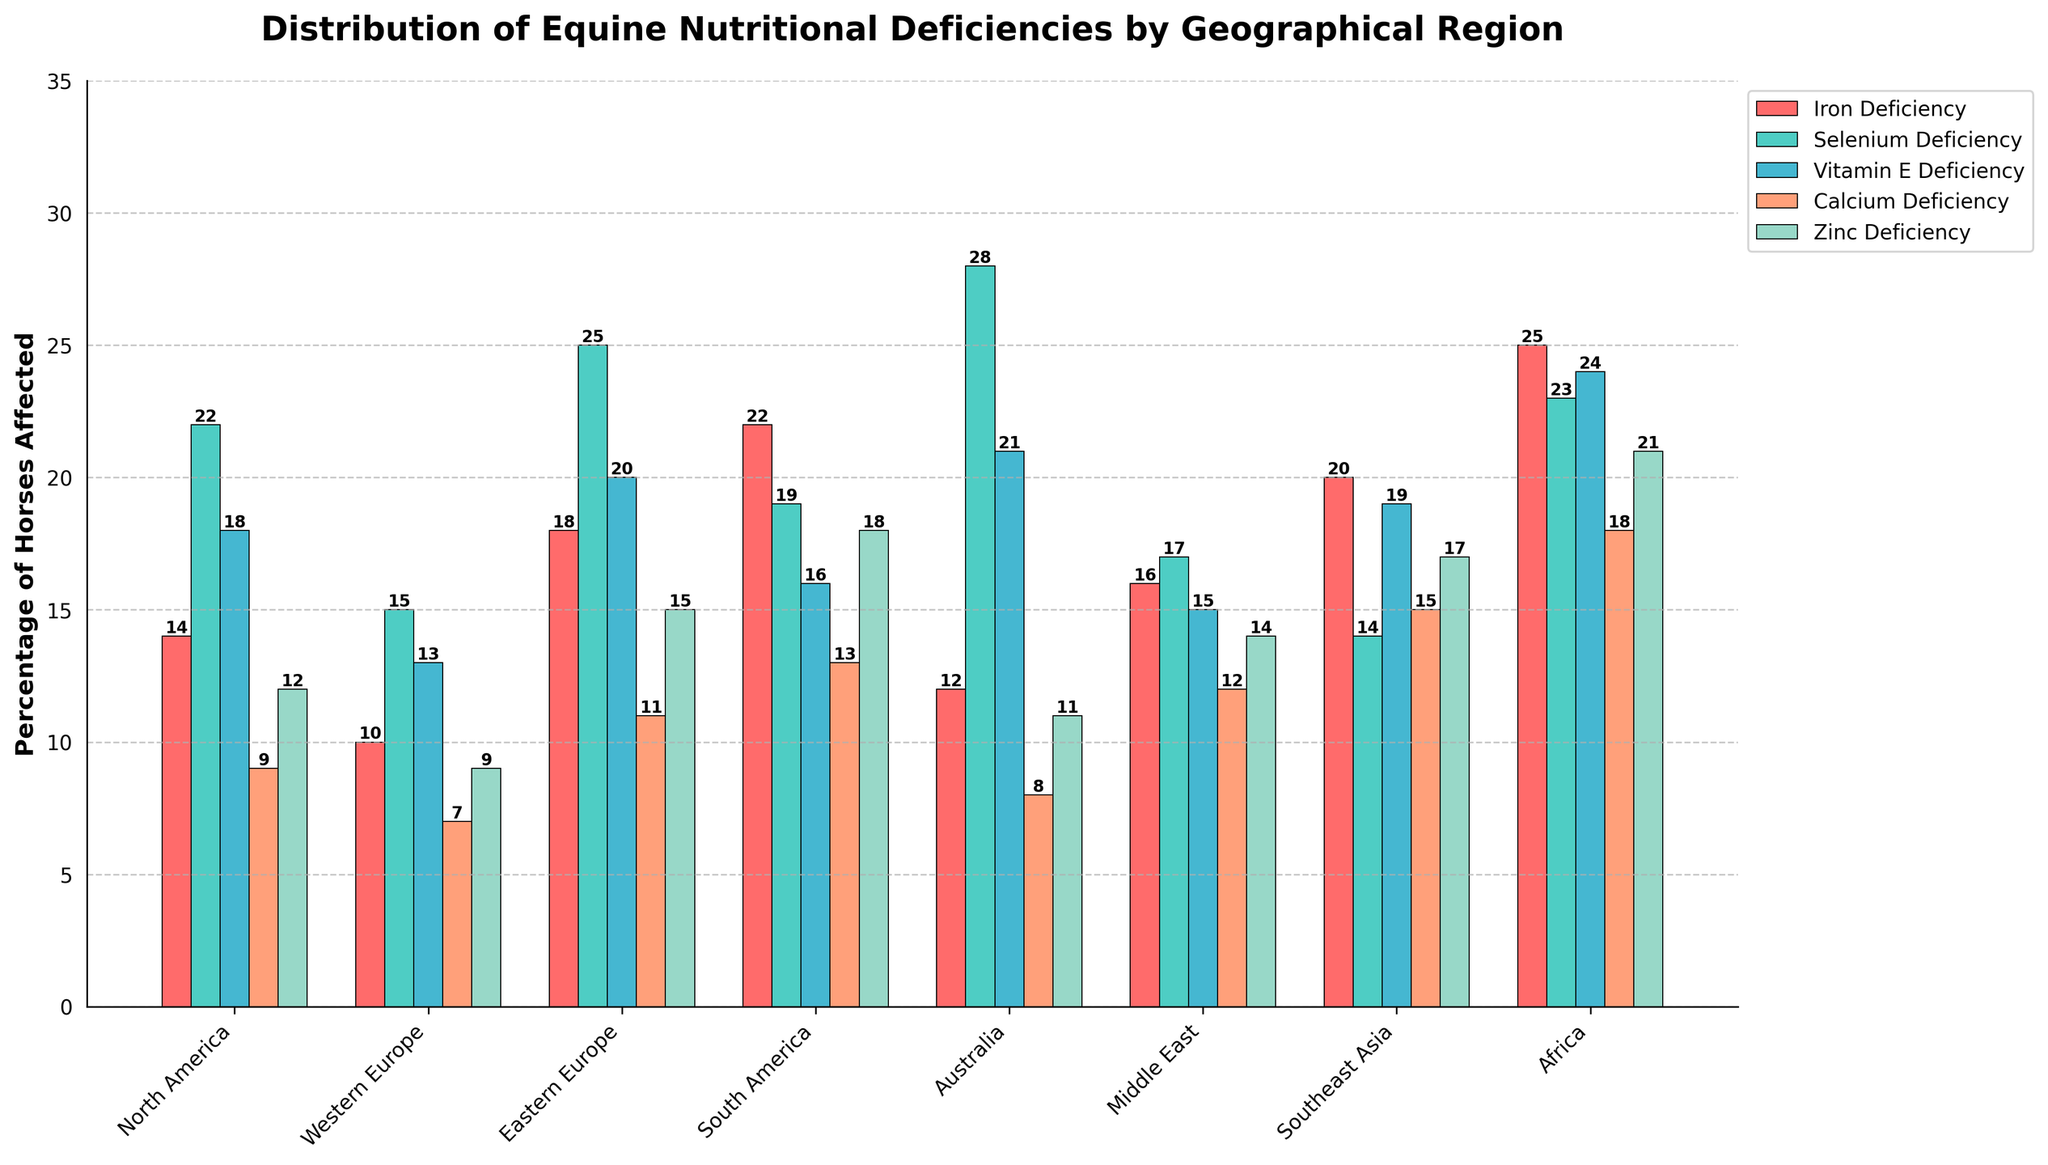Which region has the highest percentage of horses with Vitamin E Deficiency? Looking at the bar colors representing Vitamin E Deficiency, the tallest bar corresponds to Africa, indicating it has the highest percentage of horses with Vitamin E Deficiency.
Answer: Africa Which region has the fewest equine deficiencies in total? Summing the deficiencies for each region, Western Europe has the smallest overall total deficiency.
Answer: Western Europe What is the difference in the percentage of horses affected by Iron Deficiency between South America and North America? South America has 22% and North America has 14%. The difference between them is 22 - 14.
Answer: 8 Which deficiencies in Southeast Asia have higher percentages than those in the Middle East? Comparing each deficiency, Southeast Asia has higher percentages in Iron Deficiency (20 vs 16), Vitamin E Deficiency (19 vs 15), and Zinc Deficiency (17 vs 14).
Answer: Iron Deficiency, Vitamin E Deficiency, Zinc Deficiency What is the average percentage of horses affected by Selenium Deficiency across all regions? Adding the Selenium Deficiency values (22 + 15 + 25 + 19 + 28 + 17 + 14 + 23) and dividing by the number of regions (8), the average percentage is (163/8).
Answer: 20.375 Compare the percentages of Calcium Deficiency between Africa and Australia. Which has the higher value and by how much? Africa has 18%, and Australia has 8%. The difference is 18 - 8.
Answer: Africa by 10 How many regions have Zinc Deficiency percentages greater than 15%? Identifying regions with >15% for Zinc (North America: 12, Western Europe: 9, Eastern Europe: 15, South America: 18, Australia: 11, Middle East: 14, Southeast Asia: 17, Africa: 21), there are three regions with over 15%.
Answer: 3 In which regions is the percentage of Iron Deficiency greater than the percentage of Calcium Deficiency? Comparing Iron vs. Calcium Deficiencies (North America: 14 > 9, Western Europe: 10 > 7, Eastern Europe: 18 > 11, South America: 22 > 13, Australia: 12 > 8, Middle East: 16 > 12, Southeast Asia: 20 > 15, Africa: 25 > 18), in all eight regions Iron Deficiency is greater than Calcium Deficiency.
Answer: All regions What is the combined total percentage of horses affected by Selenium Deficiency and Zinc Deficiency in Western Europe? Adding Selenium (15%) and Zinc (9%) for Western Europe, the combined total is 15 + 9.
Answer: 24 Which deficiency has the most uniform distribution across all regions? Observing the variance in bar heights for each deficiency type, Zinc Deficiency appears to have relatively consistent heights across all regions.
Answer: Zinc Deficiency 